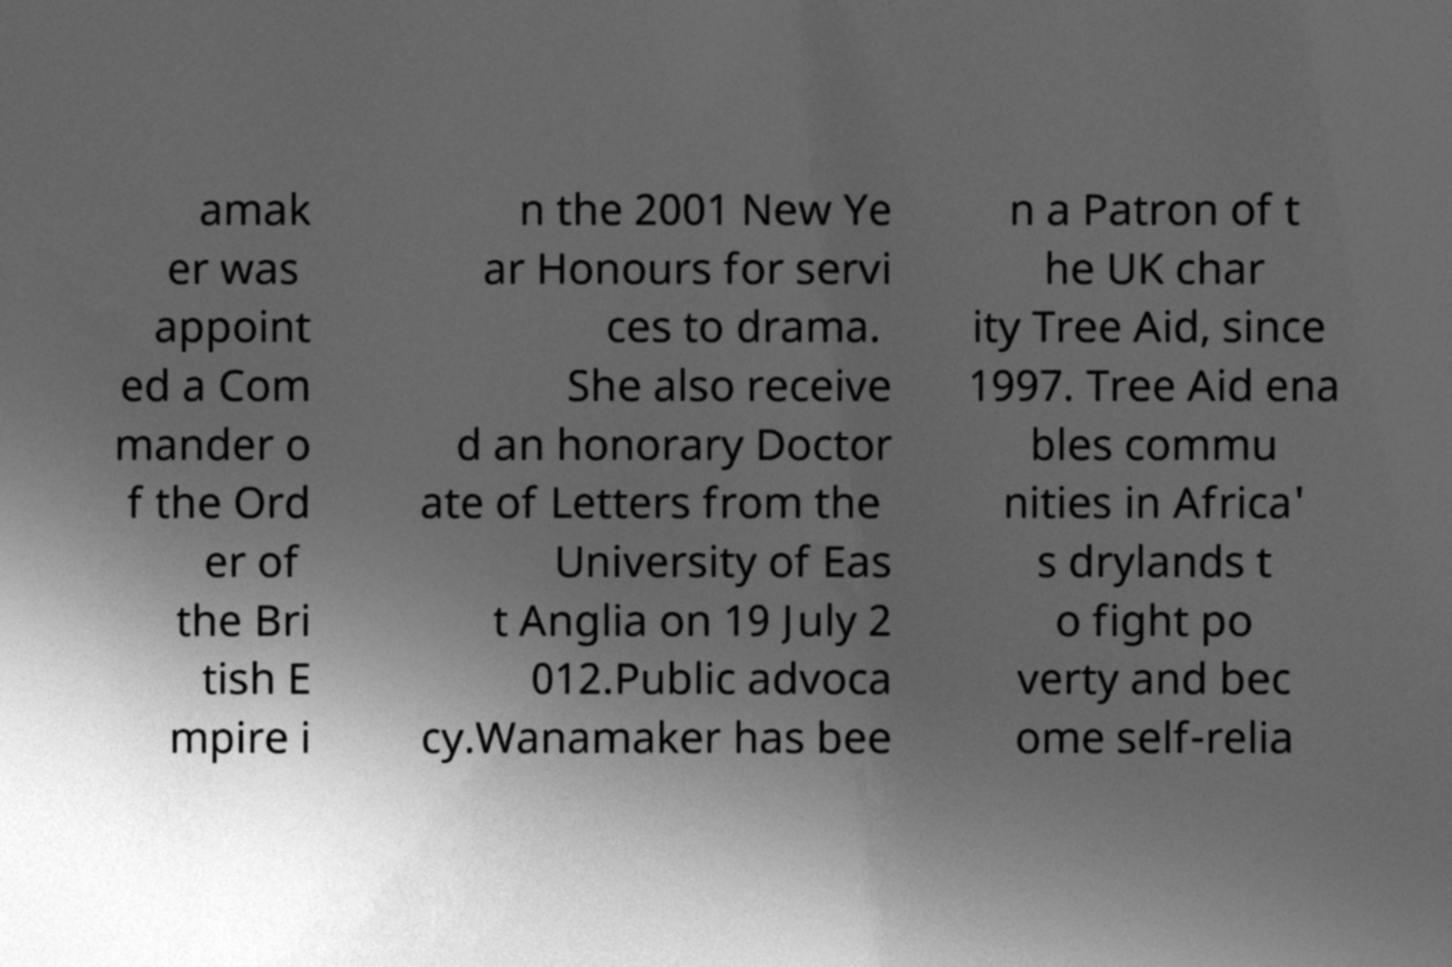I need the written content from this picture converted into text. Can you do that? amak er was appoint ed a Com mander o f the Ord er of the Bri tish E mpire i n the 2001 New Ye ar Honours for servi ces to drama. She also receive d an honorary Doctor ate of Letters from the University of Eas t Anglia on 19 July 2 012.Public advoca cy.Wanamaker has bee n a Patron of t he UK char ity Tree Aid, since 1997. Tree Aid ena bles commu nities in Africa' s drylands t o fight po verty and bec ome self-relia 